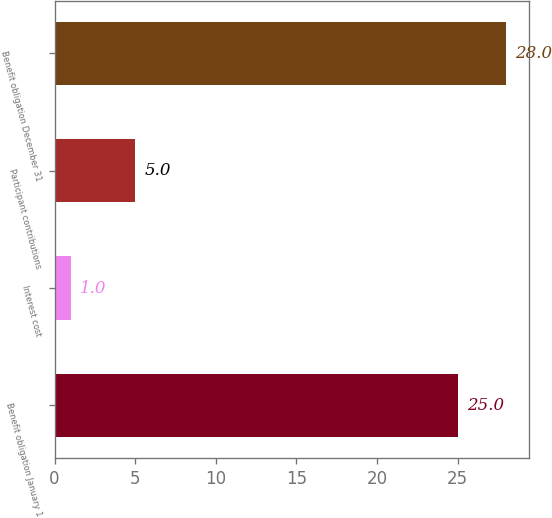<chart> <loc_0><loc_0><loc_500><loc_500><bar_chart><fcel>Benefit obligation January 1<fcel>Interest cost<fcel>Participant contributions<fcel>Benefit obligation December 31<nl><fcel>25<fcel>1<fcel>5<fcel>28<nl></chart> 